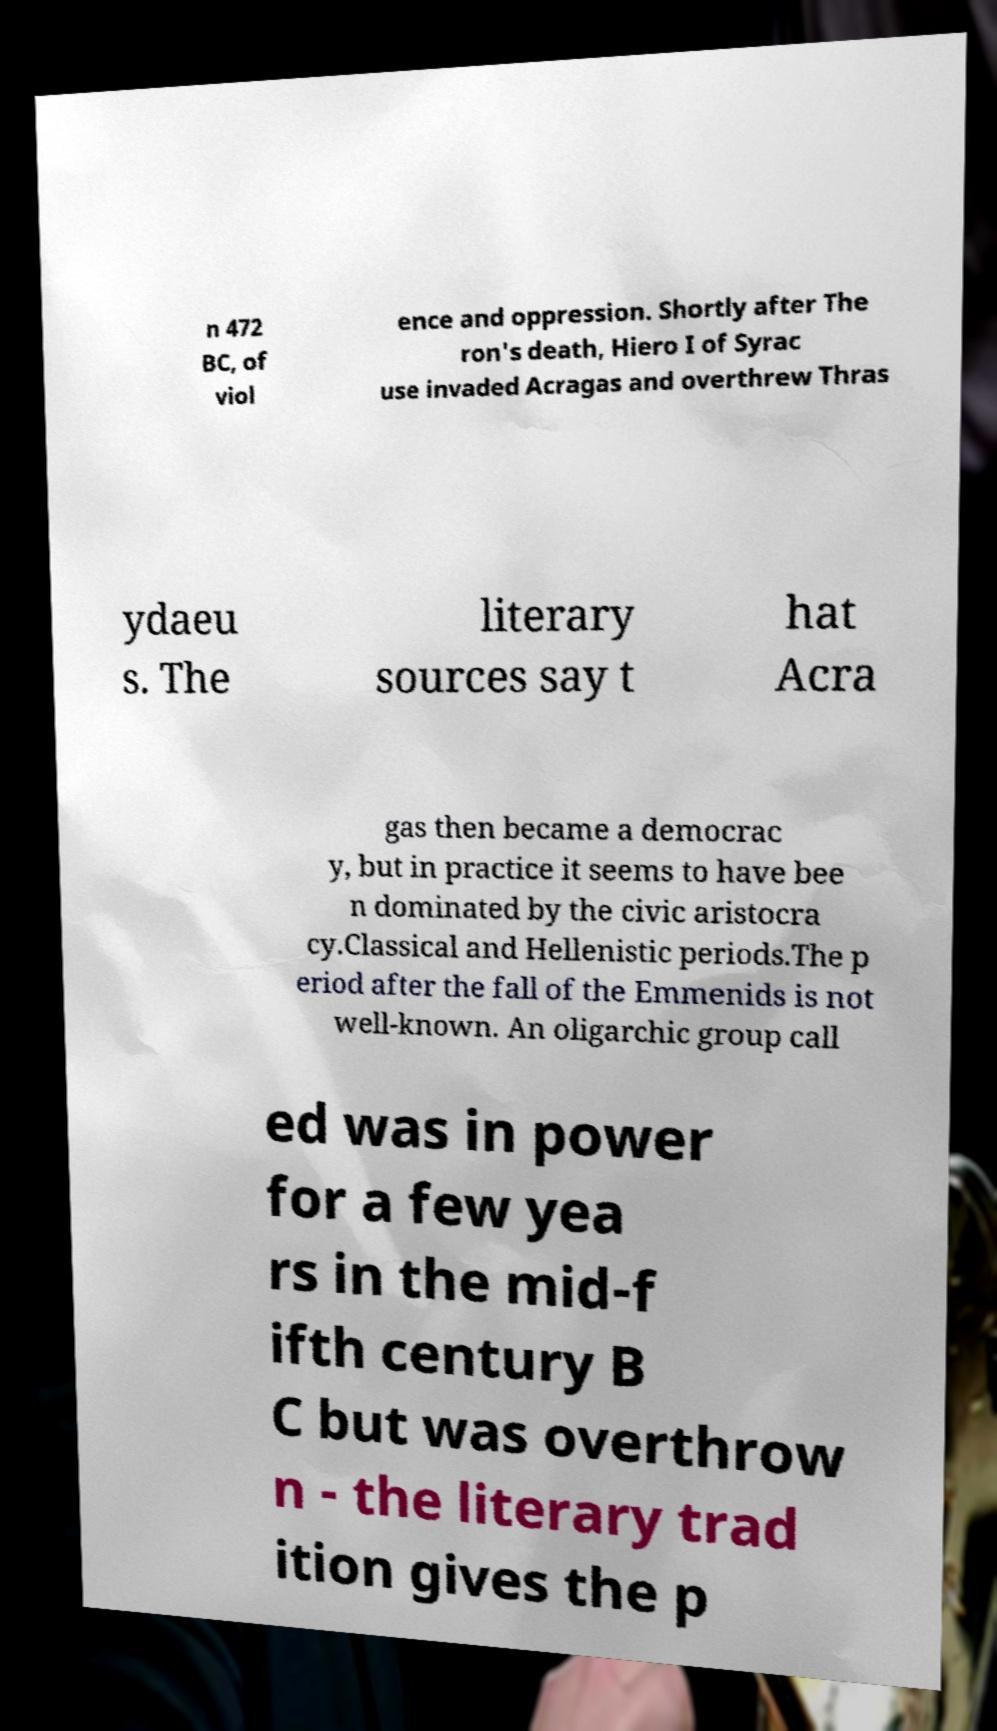Could you extract and type out the text from this image? n 472 BC, of viol ence and oppression. Shortly after The ron's death, Hiero I of Syrac use invaded Acragas and overthrew Thras ydaeu s. The literary sources say t hat Acra gas then became a democrac y, but in practice it seems to have bee n dominated by the civic aristocra cy.Classical and Hellenistic periods.The p eriod after the fall of the Emmenids is not well-known. An oligarchic group call ed was in power for a few yea rs in the mid-f ifth century B C but was overthrow n - the literary trad ition gives the p 